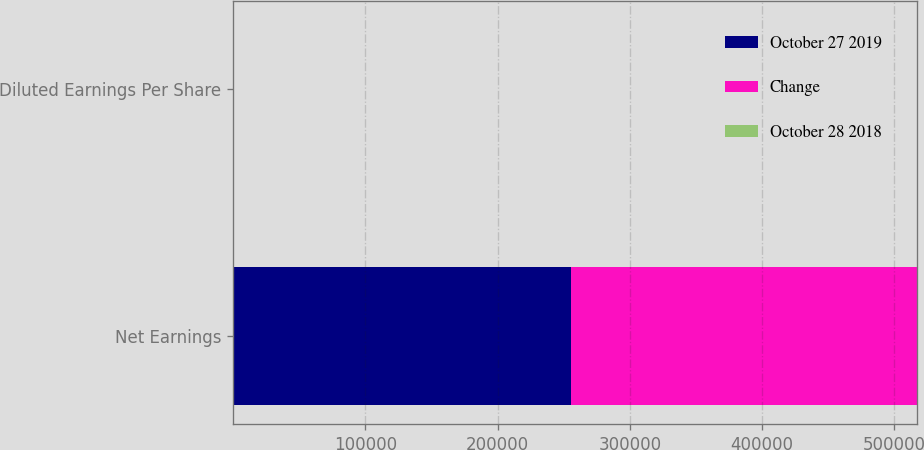Convert chart. <chart><loc_0><loc_0><loc_500><loc_500><stacked_bar_chart><ecel><fcel>Net Earnings<fcel>Diluted Earnings Per Share<nl><fcel>October 27 2019<fcel>255503<fcel>0.47<nl><fcel>Change<fcel>261406<fcel>0.48<nl><fcel>October 28 2018<fcel>2.3<fcel>2.1<nl></chart> 